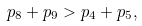<formula> <loc_0><loc_0><loc_500><loc_500>p _ { 8 } + p _ { 9 } > p _ { 4 } + p _ { 5 } ,</formula> 